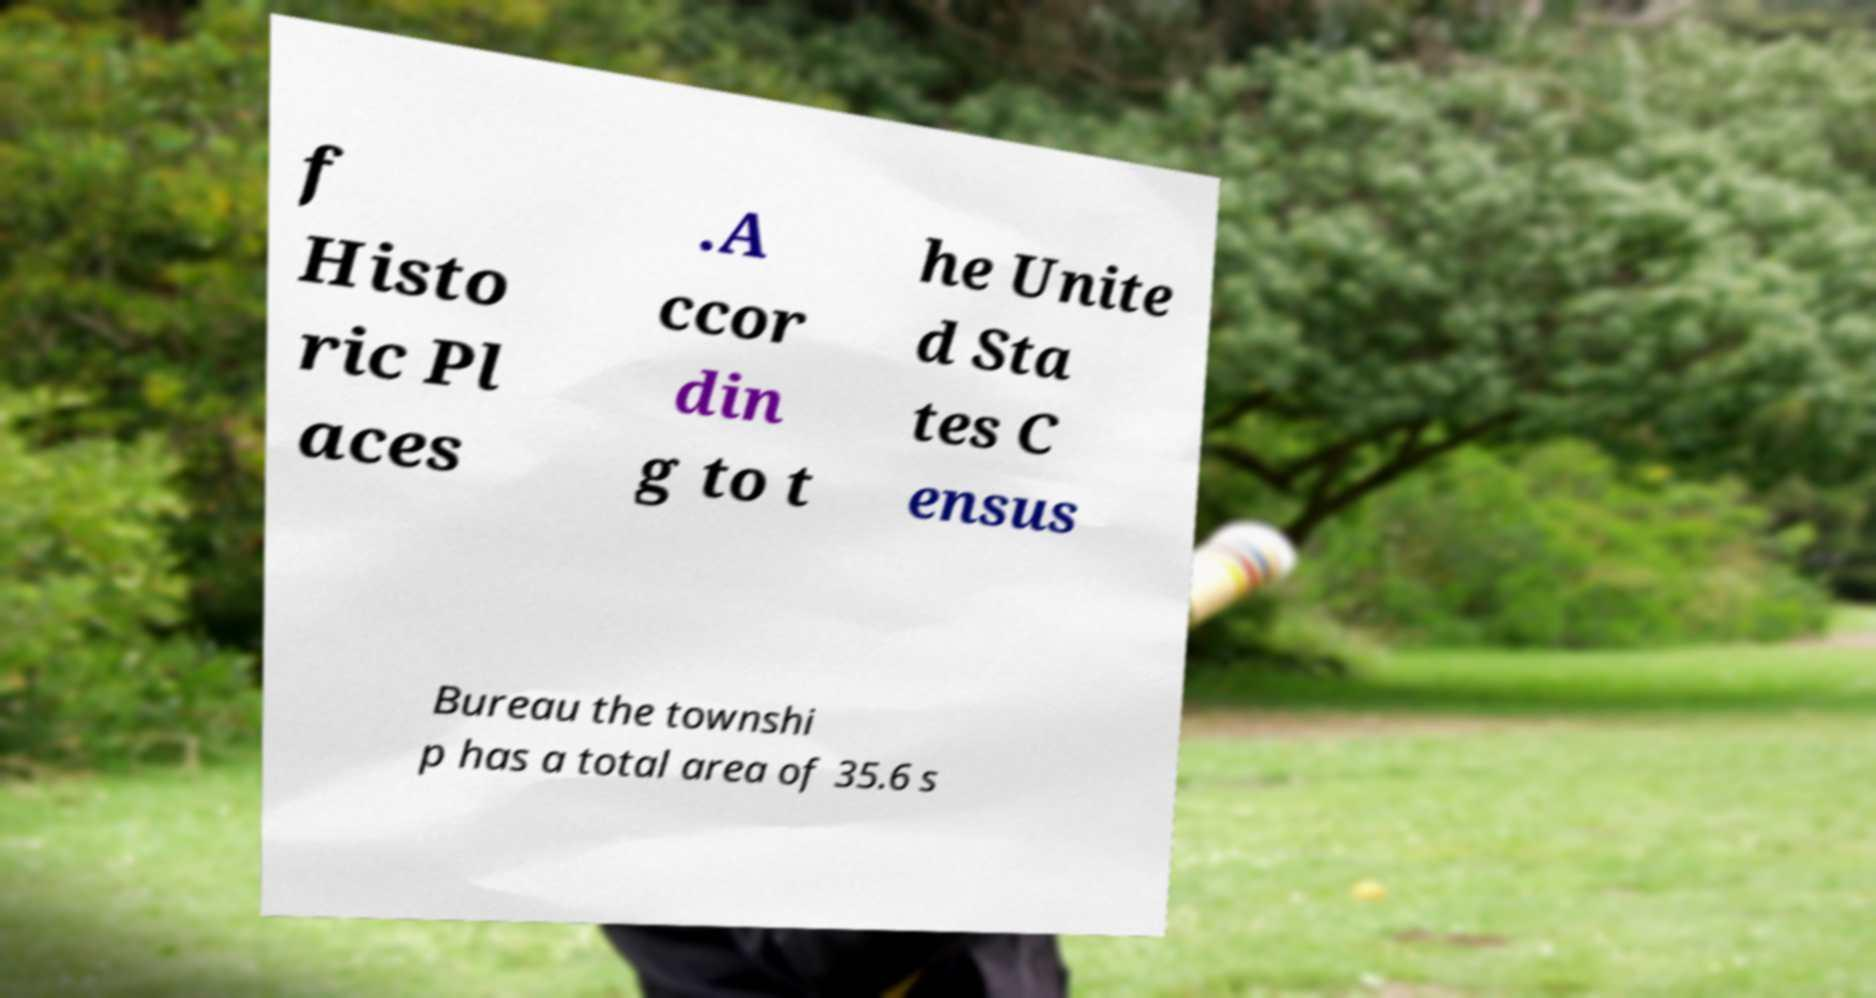Please identify and transcribe the text found in this image. f Histo ric Pl aces .A ccor din g to t he Unite d Sta tes C ensus Bureau the townshi p has a total area of 35.6 s 